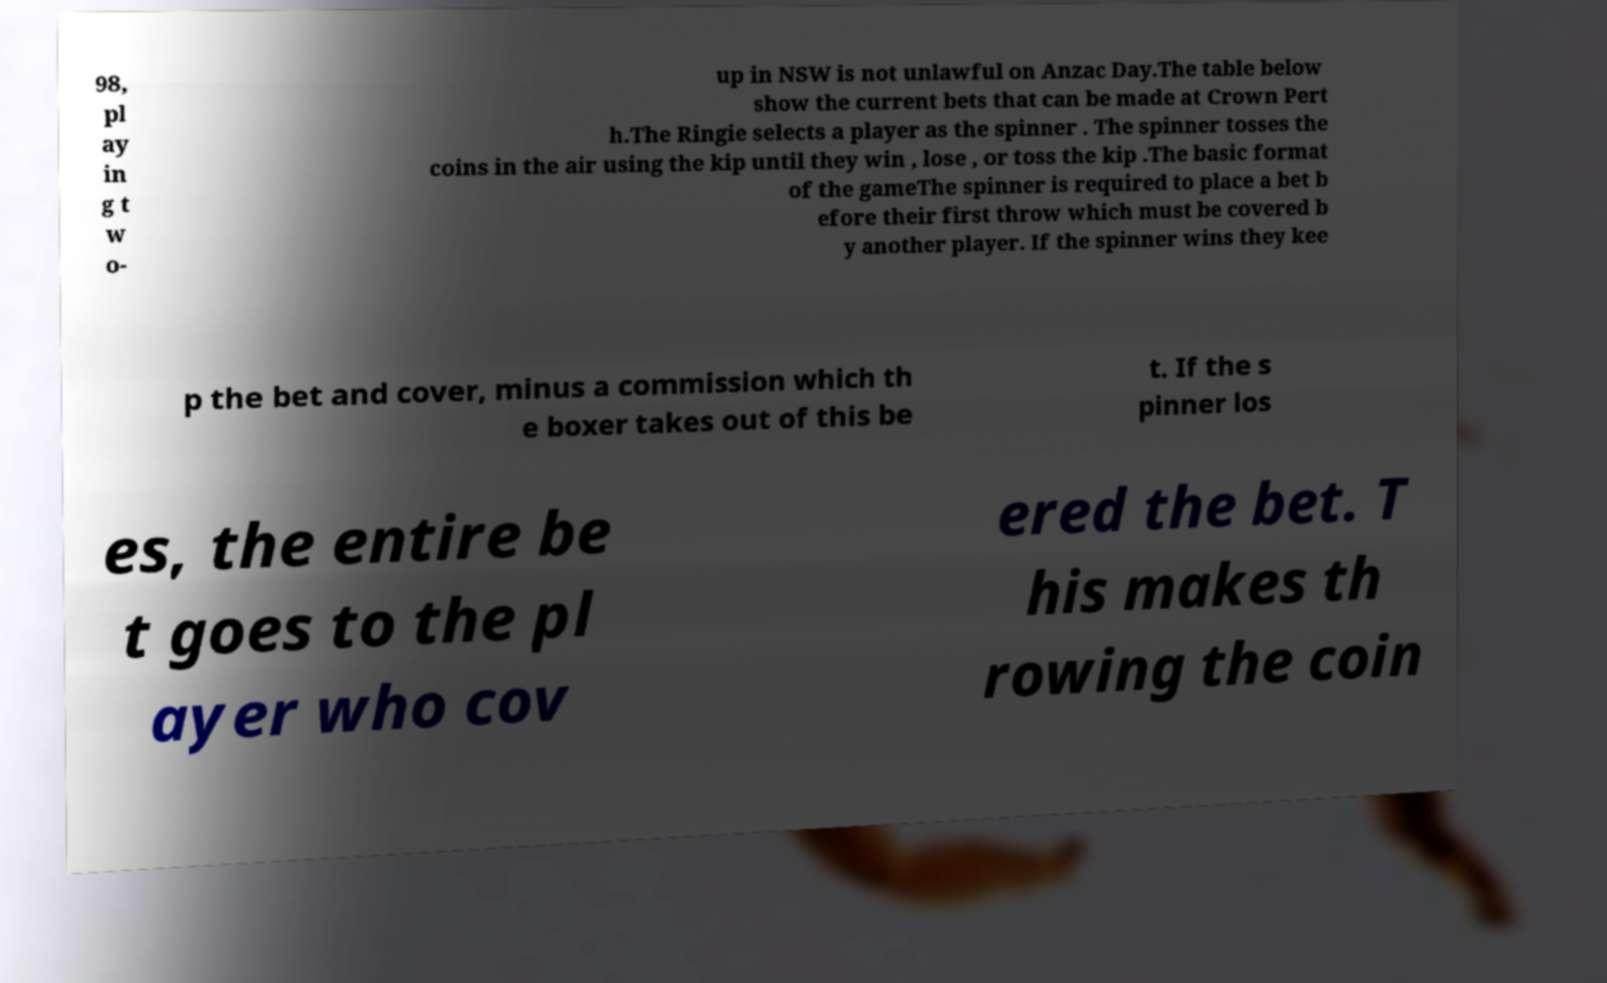Please identify and transcribe the text found in this image. 98, pl ay in g t w o- up in NSW is not unlawful on Anzac Day.The table below show the current bets that can be made at Crown Pert h.The Ringie selects a player as the spinner . The spinner tosses the coins in the air using the kip until they win , lose , or toss the kip .The basic format of the gameThe spinner is required to place a bet b efore their first throw which must be covered b y another player. If the spinner wins they kee p the bet and cover, minus a commission which th e boxer takes out of this be t. If the s pinner los es, the entire be t goes to the pl ayer who cov ered the bet. T his makes th rowing the coin 